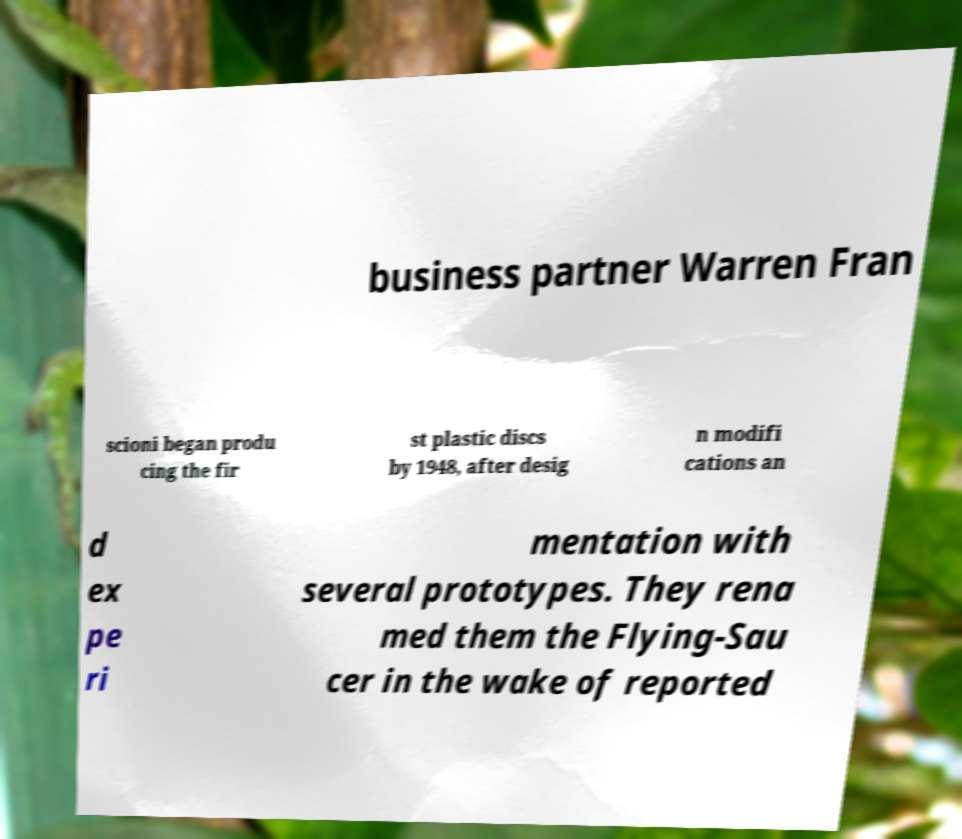For documentation purposes, I need the text within this image transcribed. Could you provide that? business partner Warren Fran scioni began produ cing the fir st plastic discs by 1948, after desig n modifi cations an d ex pe ri mentation with several prototypes. They rena med them the Flying-Sau cer in the wake of reported 